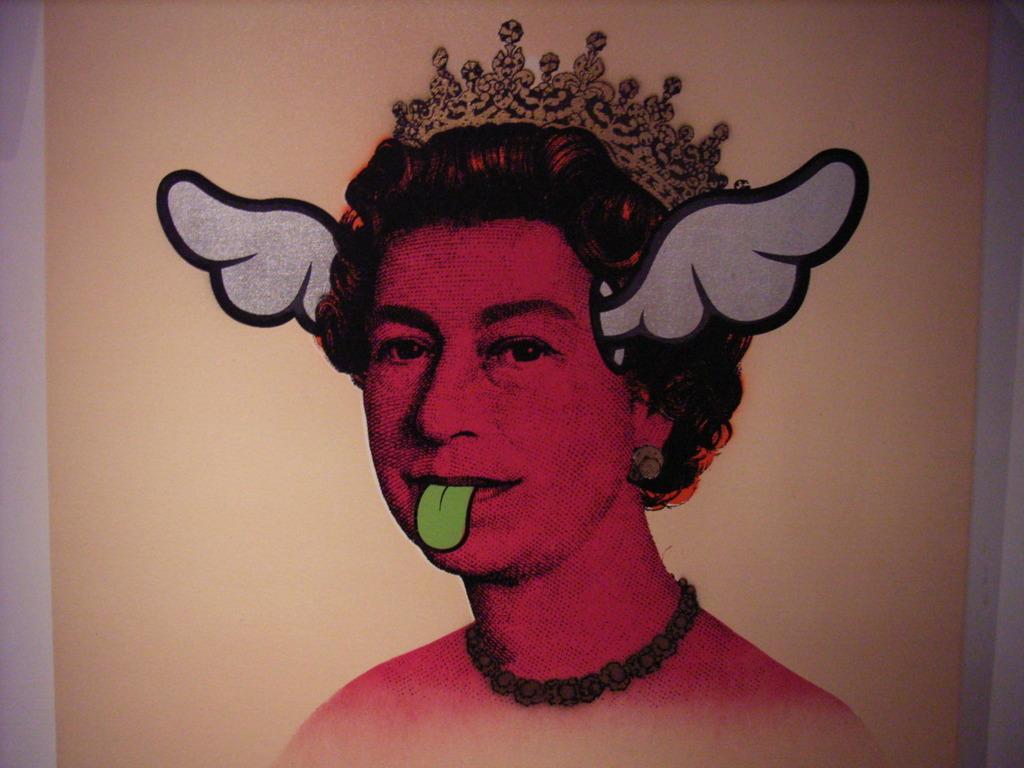Could you give a brief overview of what you see in this image? There is a painting of a person as we can see in the middle of this image. 